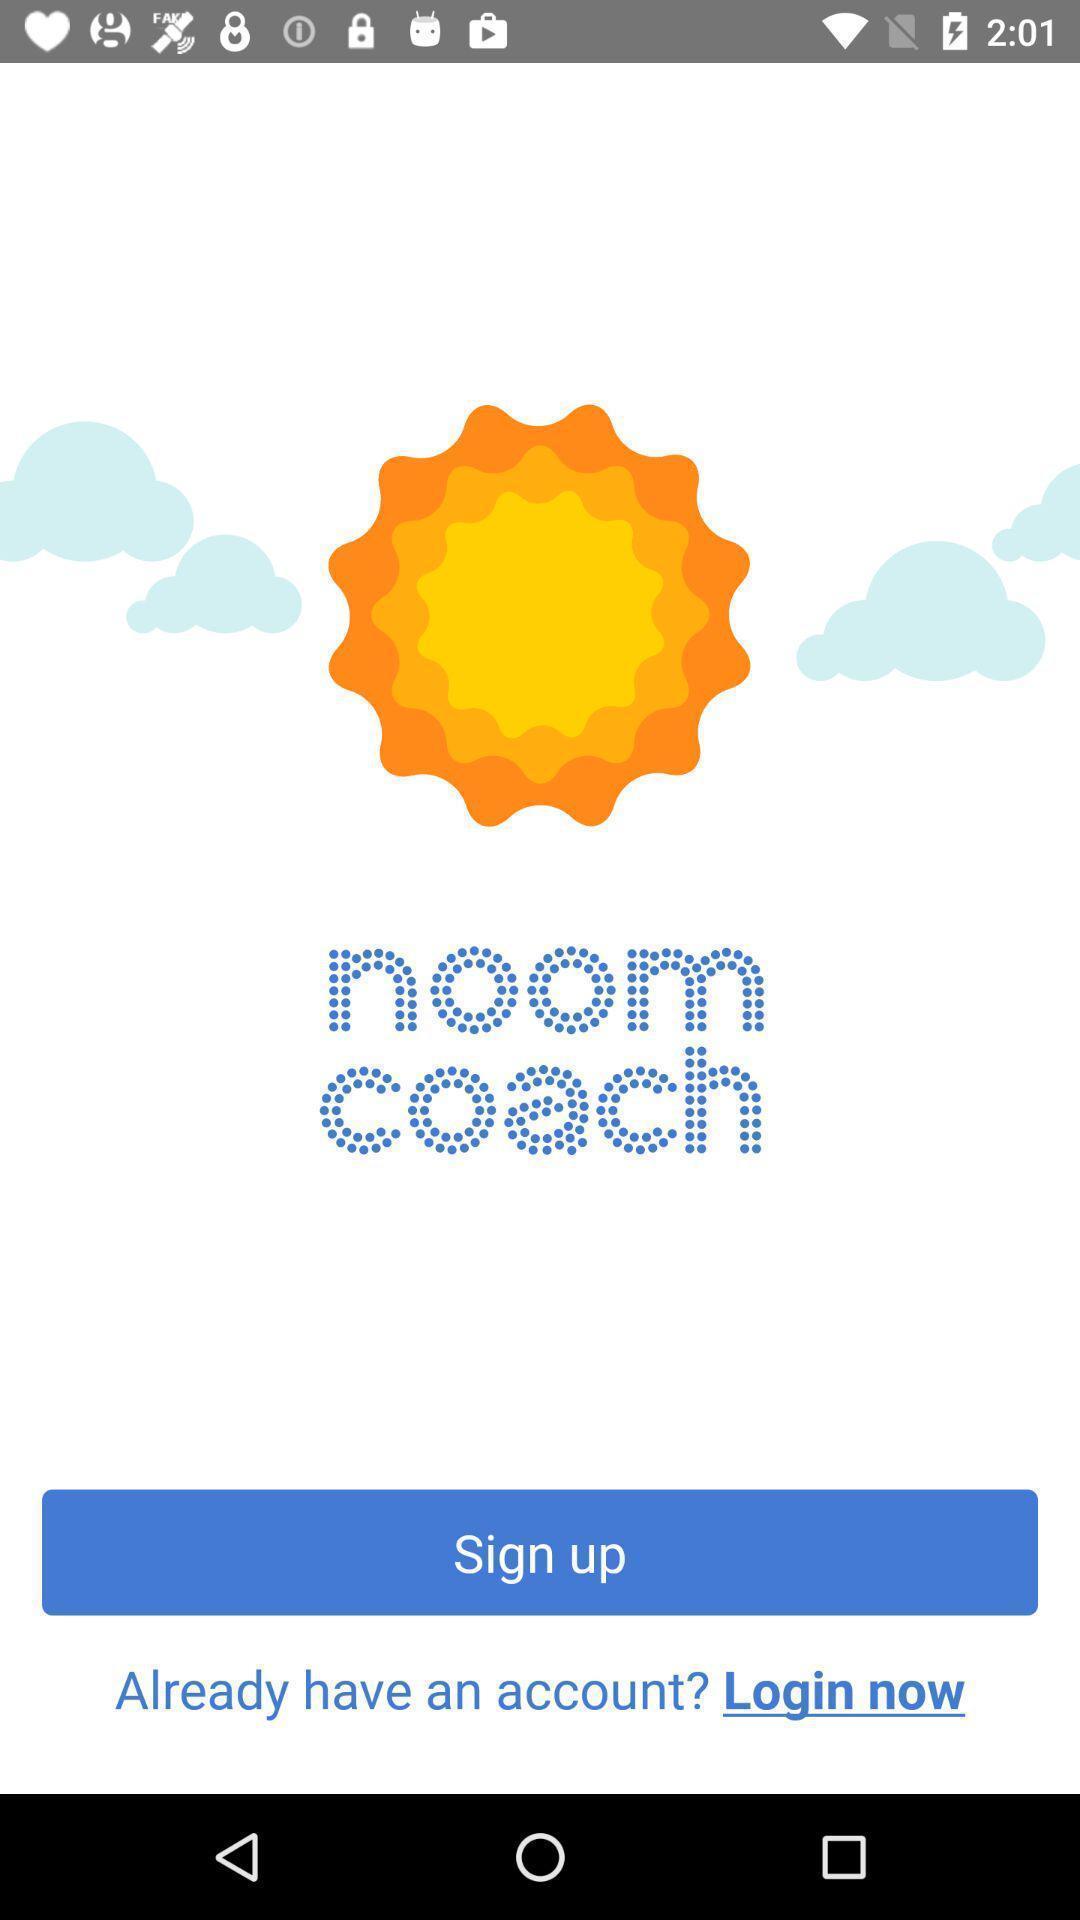Describe this image in words. Welcome page of a fitness application. 